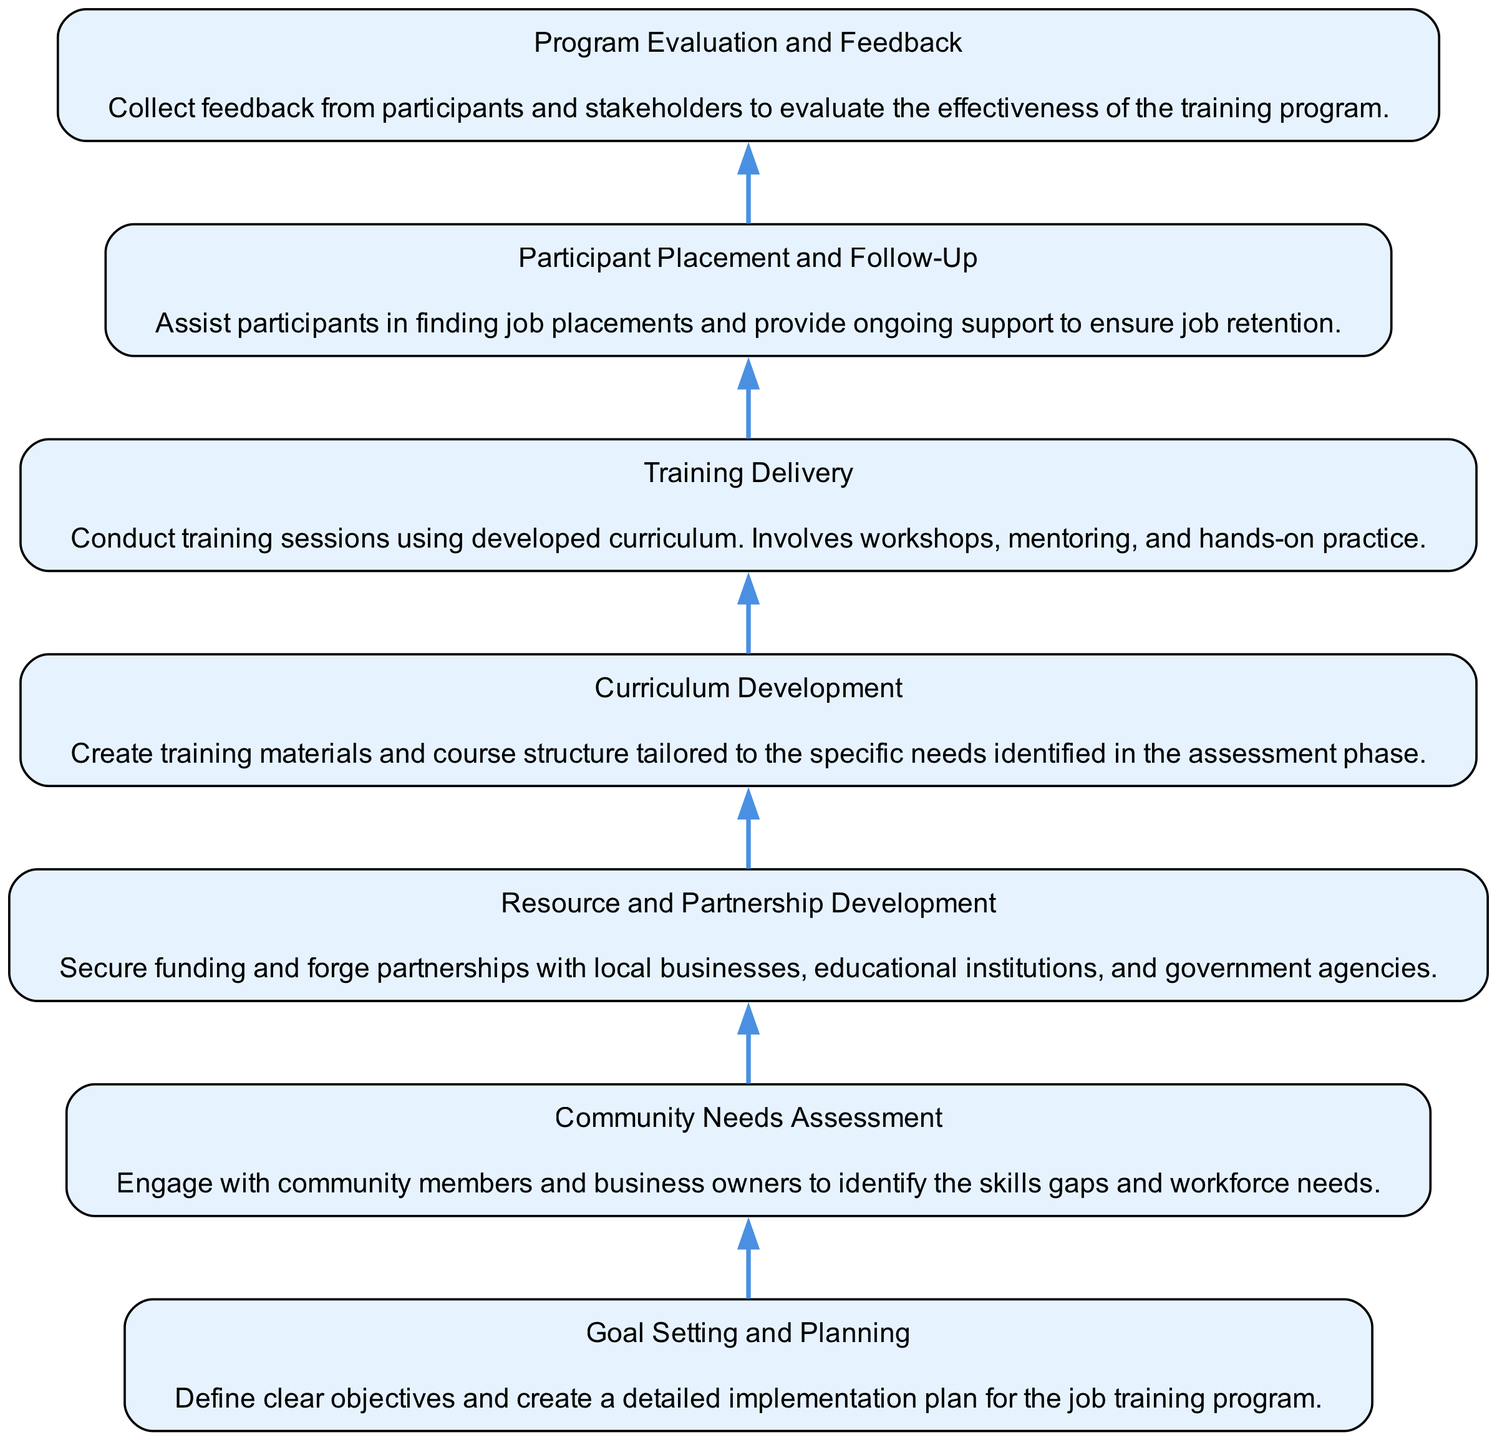What is the first step in the job training program? The last node in the flow chart represents the first step that participants will encounter in the program. In this case, it is "Goal Setting and Planning."
Answer: Goal Setting and Planning How many steps are there in the community job training program? By counting the nodes listed in the chart, we see that there are seven distinct steps.
Answer: 7 What step comes before "Training Delivery"? To find this, we look at the flow direction and identify the node that is directly above "Training Delivery," which is "Curriculum Development."
Answer: Curriculum Development What is the purpose of "Participant Placement and Follow-Up"? This step focuses on assisting trained participants to secure jobs and offering them continuous support post-placement.
Answer: Provide ongoing support to ensure job retention Which step involves creating training materials? This action is taken during the "Curriculum Development" phase, where the training materials are tailored to community needs.
Answer: Curriculum Development What do the "Resource and Partnership Development" and "Community Needs Assessment" steps have in common? Both steps are crucial for identifying resources and structures necessary for the program's success, with "Community Needs Assessment" targeting local needs and "Resource and Partnership Development" securing the necessary resources based on those needs.
Answer: Identify resources necessary for success What is the relationship between "Goal Setting and Planning" and "Community Needs Assessment"? "Goal Setting and Planning" is dependent on the insights gathered from the "Community Needs Assessment," as the needs identified inform the goals set for the training program.
Answer: Curriculum Development informs Goal Setting How does the flow direction of this diagram impact understanding? The flow direction from bottom to top suggests a chronological sequence, emphasizing that each step builds upon the previous one, making it clear how one phase leads to the next in implementing the job training program.
Answer: Indicates chronological sequence 